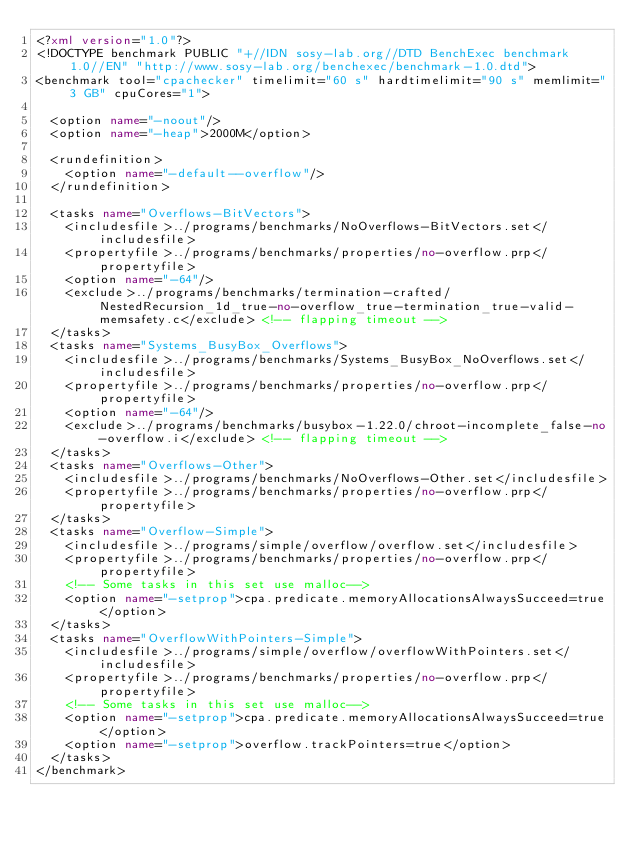Convert code to text. <code><loc_0><loc_0><loc_500><loc_500><_XML_><?xml version="1.0"?>
<!DOCTYPE benchmark PUBLIC "+//IDN sosy-lab.org//DTD BenchExec benchmark 1.0//EN" "http://www.sosy-lab.org/benchexec/benchmark-1.0.dtd">
<benchmark tool="cpachecker" timelimit="60 s" hardtimelimit="90 s" memlimit="3 GB" cpuCores="1">

  <option name="-noout"/>
  <option name="-heap">2000M</option>

  <rundefinition>
    <option name="-default--overflow"/>
  </rundefinition>

  <tasks name="Overflows-BitVectors">
    <includesfile>../programs/benchmarks/NoOverflows-BitVectors.set</includesfile>
    <propertyfile>../programs/benchmarks/properties/no-overflow.prp</propertyfile>
    <option name="-64"/>
    <exclude>../programs/benchmarks/termination-crafted/NestedRecursion_1d_true-no-overflow_true-termination_true-valid-memsafety.c</exclude> <!-- flapping timeout -->
  </tasks>
  <tasks name="Systems_BusyBox_Overflows">
    <includesfile>../programs/benchmarks/Systems_BusyBox_NoOverflows.set</includesfile>
    <propertyfile>../programs/benchmarks/properties/no-overflow.prp</propertyfile>
    <option name="-64"/>
    <exclude>../programs/benchmarks/busybox-1.22.0/chroot-incomplete_false-no-overflow.i</exclude> <!-- flapping timeout -->
  </tasks>
  <tasks name="Overflows-Other">
    <includesfile>../programs/benchmarks/NoOverflows-Other.set</includesfile>
    <propertyfile>../programs/benchmarks/properties/no-overflow.prp</propertyfile>
  </tasks>
  <tasks name="Overflow-Simple">
    <includesfile>../programs/simple/overflow/overflow.set</includesfile>
    <propertyfile>../programs/benchmarks/properties/no-overflow.prp</propertyfile>
    <!-- Some tasks in this set use malloc-->
    <option name="-setprop">cpa.predicate.memoryAllocationsAlwaysSucceed=true</option>
  </tasks>
  <tasks name="OverflowWithPointers-Simple">
    <includesfile>../programs/simple/overflow/overflowWithPointers.set</includesfile>
    <propertyfile>../programs/benchmarks/properties/no-overflow.prp</propertyfile>
    <!-- Some tasks in this set use malloc-->
    <option name="-setprop">cpa.predicate.memoryAllocationsAlwaysSucceed=true</option>
    <option name="-setprop">overflow.trackPointers=true</option>
  </tasks>
</benchmark>
</code> 